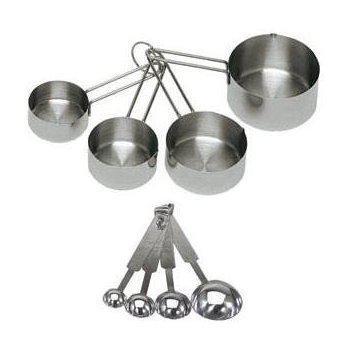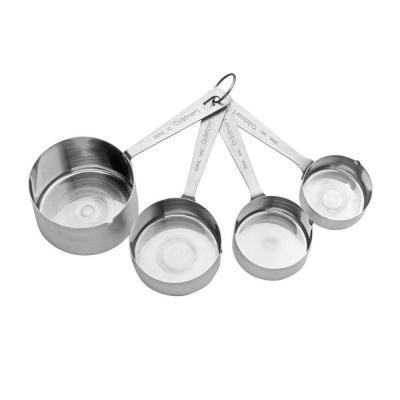The first image is the image on the left, the second image is the image on the right. Assess this claim about the two images: "Exactly two sets of measuring cups and spoons are fanned for display.". Correct or not? Answer yes or no. No. 